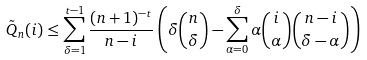Convert formula to latex. <formula><loc_0><loc_0><loc_500><loc_500>\tilde { Q } _ { n } ( i ) & \leq \sum _ { \delta = 1 } ^ { t - 1 } \frac { ( n + 1 ) ^ { - t } } { n - i } \left ( \delta \binom { n } { \delta } - \sum _ { \alpha = 0 } ^ { \delta } \alpha \binom { i } { \alpha } \binom { n - i } { \delta - \alpha } \right )</formula> 